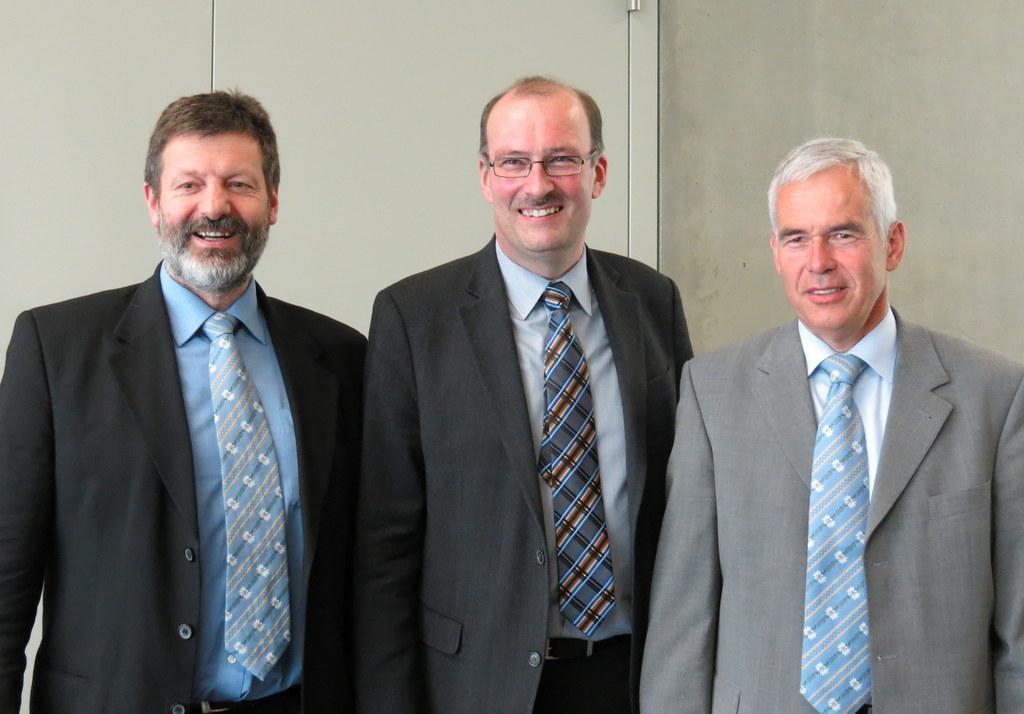In one or two sentences, can you explain what this image depicts? In this image, we can see people standing, smiling and wearing coats and ties and one of them is wearing glasses. In the background, there is a wall. 